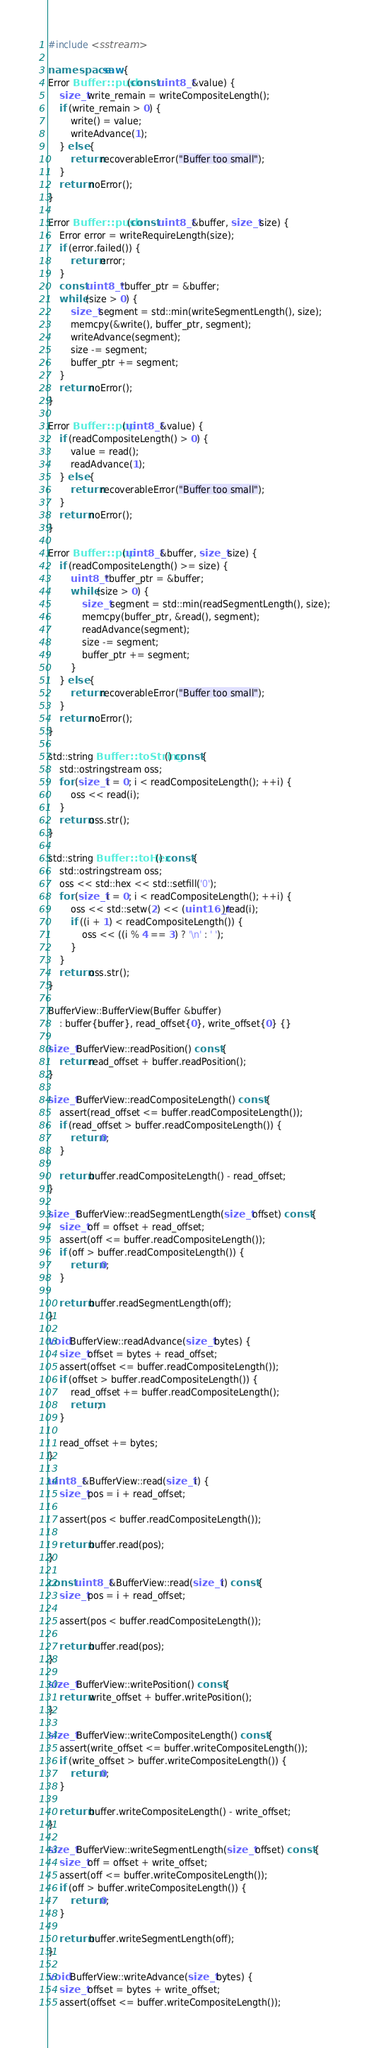Convert code to text. <code><loc_0><loc_0><loc_500><loc_500><_C++_>#include <sstream>

namespace saw {
Error Buffer::push(const uint8_t &value) {
	size_t write_remain = writeCompositeLength();
	if (write_remain > 0) {
		write() = value;
		writeAdvance(1);
	} else {
		return recoverableError("Buffer too small");
	}
	return noError();
}

Error Buffer::push(const uint8_t &buffer, size_t size) {
	Error error = writeRequireLength(size);
	if (error.failed()) {
		return error;
	}
	const uint8_t *buffer_ptr = &buffer;
	while (size > 0) {
		size_t segment = std::min(writeSegmentLength(), size);
		memcpy(&write(), buffer_ptr, segment);
		writeAdvance(segment);
		size -= segment;
		buffer_ptr += segment;
	}
	return noError();
}

Error Buffer::pop(uint8_t &value) {
	if (readCompositeLength() > 0) {
		value = read();
		readAdvance(1);
	} else {
		return recoverableError("Buffer too small");
	}
	return noError();
}

Error Buffer::pop(uint8_t &buffer, size_t size) {
	if (readCompositeLength() >= size) {
		uint8_t *buffer_ptr = &buffer;
		while (size > 0) {
			size_t segment = std::min(readSegmentLength(), size);
			memcpy(buffer_ptr, &read(), segment);
			readAdvance(segment);
			size -= segment;
			buffer_ptr += segment;
		}
	} else {
		return recoverableError("Buffer too small");
	}
	return noError();
}

std::string Buffer::toString() const {
	std::ostringstream oss;
	for (size_t i = 0; i < readCompositeLength(); ++i) {
		oss << read(i);
	}
	return oss.str();
}

std::string Buffer::toHex() const {
	std::ostringstream oss;
	oss << std::hex << std::setfill('0');
	for (size_t i = 0; i < readCompositeLength(); ++i) {
		oss << std::setw(2) << (uint16_t)read(i);
		if ((i + 1) < readCompositeLength()) {
			oss << ((i % 4 == 3) ? '\n' : ' ');
		}
	}
	return oss.str();
}

BufferView::BufferView(Buffer &buffer)
	: buffer{buffer}, read_offset{0}, write_offset{0} {}

size_t BufferView::readPosition() const {
	return read_offset + buffer.readPosition();
}

size_t BufferView::readCompositeLength() const {
	assert(read_offset <= buffer.readCompositeLength());
	if (read_offset > buffer.readCompositeLength()) {
		return 0;
	}

	return buffer.readCompositeLength() - read_offset;
}

size_t BufferView::readSegmentLength(size_t offset) const {
	size_t off = offset + read_offset;
	assert(off <= buffer.readCompositeLength());
	if (off > buffer.readCompositeLength()) {
		return 0;
	}

	return buffer.readSegmentLength(off);
}

void BufferView::readAdvance(size_t bytes) {
	size_t offset = bytes + read_offset;
	assert(offset <= buffer.readCompositeLength());
	if (offset > buffer.readCompositeLength()) {
		read_offset += buffer.readCompositeLength();
		return;
	}

	read_offset += bytes;
}

uint8_t &BufferView::read(size_t i) {
	size_t pos = i + read_offset;

	assert(pos < buffer.readCompositeLength());

	return buffer.read(pos);
}

const uint8_t &BufferView::read(size_t i) const {
	size_t pos = i + read_offset;

	assert(pos < buffer.readCompositeLength());

	return buffer.read(pos);
}

size_t BufferView::writePosition() const {
	return write_offset + buffer.writePosition();
}

size_t BufferView::writeCompositeLength() const {
	assert(write_offset <= buffer.writeCompositeLength());
	if (write_offset > buffer.writeCompositeLength()) {
		return 0;
	}

	return buffer.writeCompositeLength() - write_offset;
}

size_t BufferView::writeSegmentLength(size_t offset) const {
	size_t off = offset + write_offset;
	assert(off <= buffer.writeCompositeLength());
	if (off > buffer.writeCompositeLength()) {
		return 0;
	}

	return buffer.writeSegmentLength(off);
}

void BufferView::writeAdvance(size_t bytes) {
	size_t offset = bytes + write_offset;
	assert(offset <= buffer.writeCompositeLength());</code> 